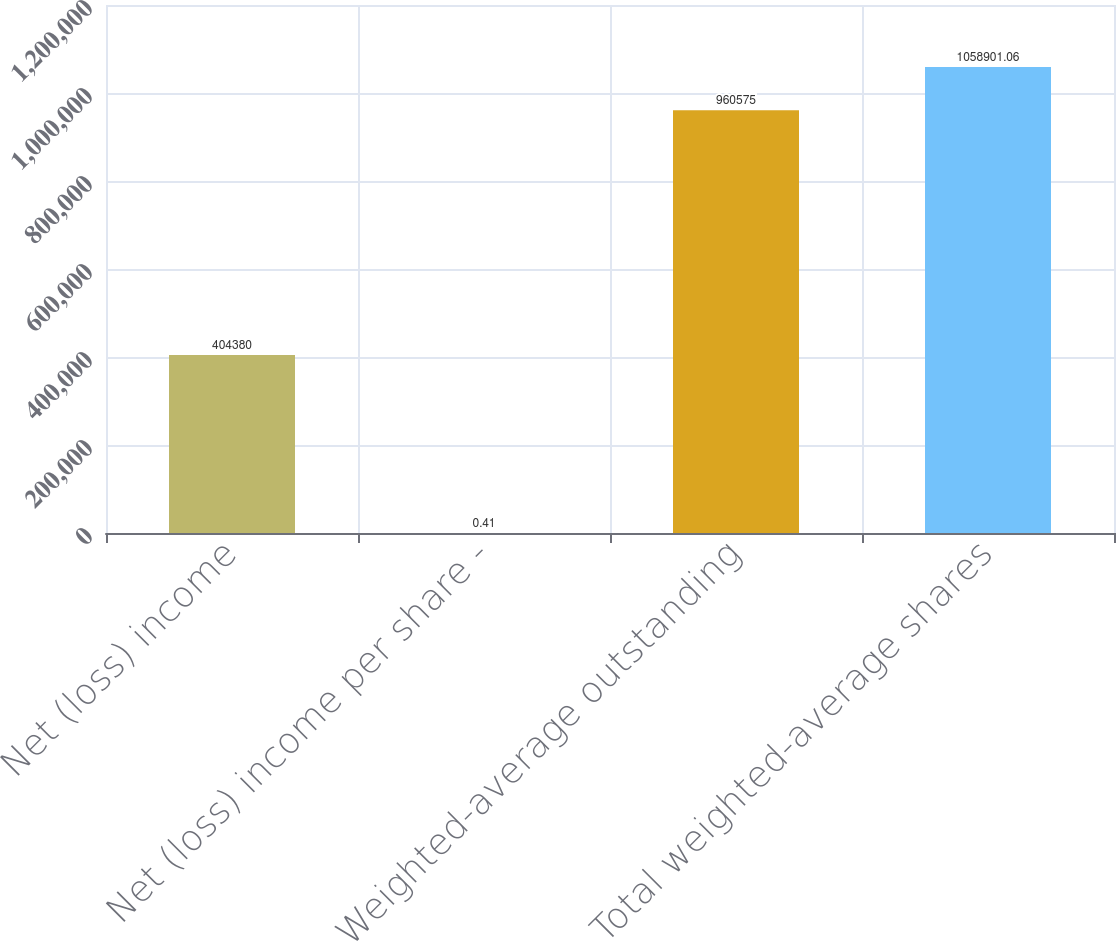Convert chart to OTSL. <chart><loc_0><loc_0><loc_500><loc_500><bar_chart><fcel>Net (loss) income<fcel>Net (loss) income per share -<fcel>Weighted-average outstanding<fcel>Total weighted-average shares<nl><fcel>404380<fcel>0.41<fcel>960575<fcel>1.0589e+06<nl></chart> 